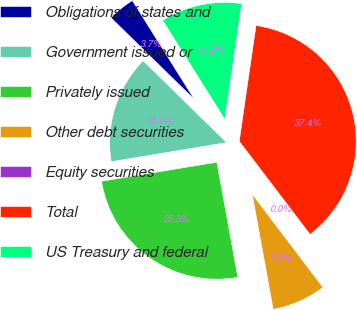Convert chart. <chart><loc_0><loc_0><loc_500><loc_500><pie_chart><fcel>Obligations of states and<fcel>Government issued or<fcel>Privately issued<fcel>Other debt securities<fcel>Equity securities<fcel>Total<fcel>US Treasury and federal<nl><fcel>3.74%<fcel>14.95%<fcel>25.26%<fcel>7.47%<fcel>0.0%<fcel>37.37%<fcel>11.21%<nl></chart> 